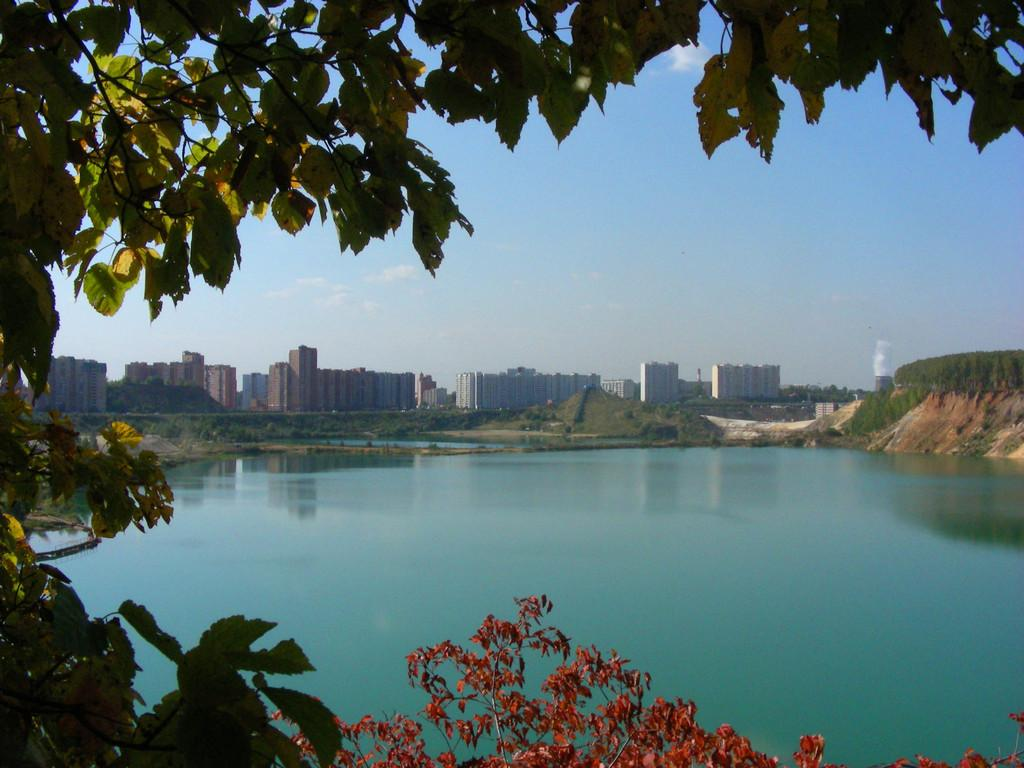What is the main feature in the center of the image? There is a lake in the center of the image. What type of vegetation can be seen in the image? Trees are visible in the image. What can be seen in the background of the image? There are buildings and the sky visible in the background of the image. What is located on the right side of the image? There is a rock on the right side of the image. Can you see a zebra or a yak in the image? No, there are no zebras or yaks present in the image. 